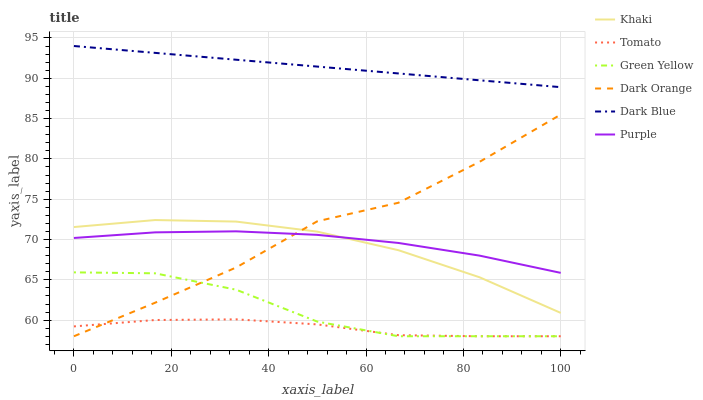Does Dark Orange have the minimum area under the curve?
Answer yes or no. No. Does Dark Orange have the maximum area under the curve?
Answer yes or no. No. Is Khaki the smoothest?
Answer yes or no. No. Is Khaki the roughest?
Answer yes or no. No. Does Khaki have the lowest value?
Answer yes or no. No. Does Dark Orange have the highest value?
Answer yes or no. No. Is Green Yellow less than Purple?
Answer yes or no. Yes. Is Dark Blue greater than Khaki?
Answer yes or no. Yes. Does Green Yellow intersect Purple?
Answer yes or no. No. 